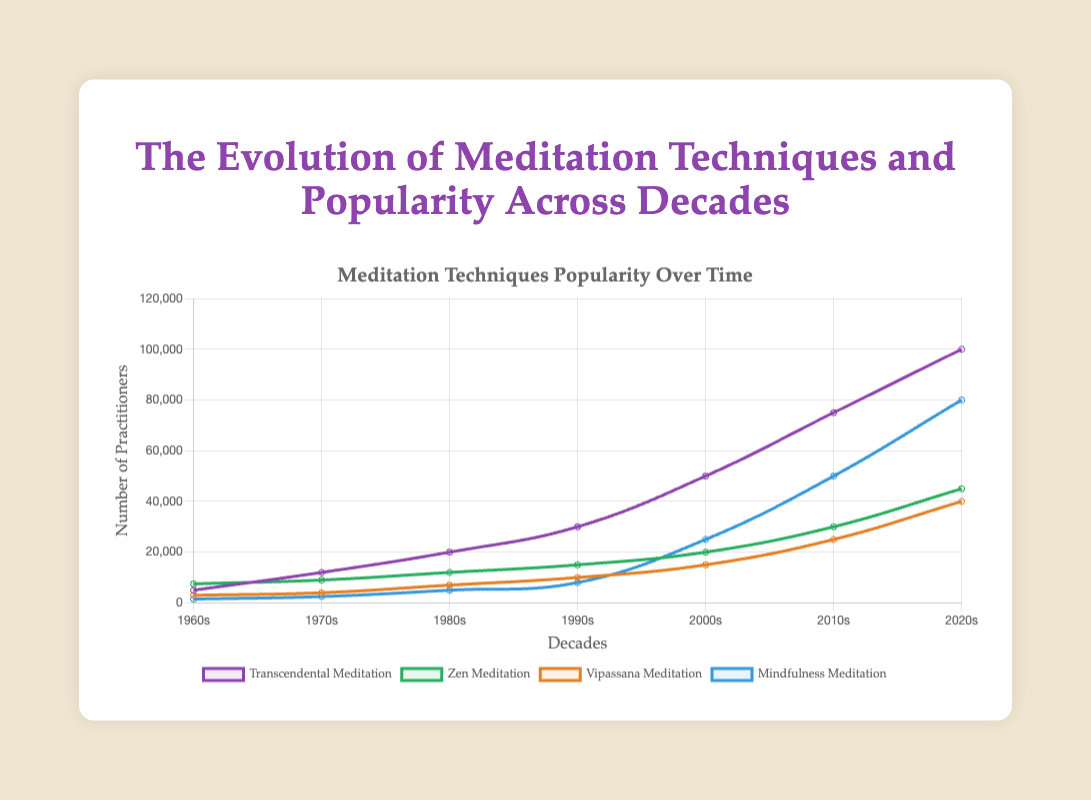Which meditation technique had the highest number of practitioners in the 1960s? The line chart shows the number of practitioners of different meditation techniques across decades. In the 1960s, Zen Meditation had the highest number of practitioners with 7500.
Answer: Zen Meditation What is the difference in the number of practitioners between Vipassana Meditation and Mindfulness Meditation in the 2020s? The chart indicates the number of practitioners for Vipassana Meditation as 40000 and Mindfulness Meditation as 80000 in the 2020s. Subtracting the two gives 80000 - 40000 = 40000.
Answer: 40000 Which meditation technique saw the largest growth in popularity from the 2000s to the 2010s? By observing the increase in the number of practitioners from the 2000s to the 2010s, Mindfulness Meditation grew from 25000 to 50000, Transcendental Meditation from 50000 to 75000, Zen Meditation from 20000 to 30000, and Vipassana Meditation from 15000 to 25000. The largest growth was for Mindfulness Meditation, which increased by 25000.
Answer: Mindfulness Meditation What is the combined number of practitioners for all meditation techniques in the 1980s? Add the number of practitioners for all techniques in the 1980s: (20000 for Transcendental Meditation) + (12000 for Zen Meditation) + (7000 for Vipassana Meditation) + (5000 for Mindfulness Meditation). Total = 20000 + 12000 + 7000 + 5000 = 44000.
Answer: 44000 Which decade saw the highest increase in the number of practitioners for Transcendental Meditation? Observing the increments across the decades: 1960s to 1970s (5000 to 12000 = 7000), 1970s to 1980s (12000 to 20000 = 8000), 1980s to 1990s (20000 to 30000 = 10000), 1990s to 2000s (30000 to 50000 = 20000), 2000s to 2010s (50000 to 75000 = 25000), 2010s to 2020s (75000 to 100000 = 25000). The highest increase was from the 2000s to 2010s and 2010s to 2020s, both with an increase of 25000.
Answer: 2000s to 2010s, 2010s to 2020s Which meditation technique had a consistent increase in practitioners across all decades? By analyzing the data, all the techniques (Transcendental Meditation, Zen Meditation, Vipassana Meditation, Mindfulness Meditation) had an increase in the number of practitioners across all decades without any decline.
Answer: All techniques Rank the meditation techniques based on the number of practitioners in the 2020s from highest to lowest. By referring to the chart for the 2020s: Transcendental Meditation (100000), Mindfulness Meditation (80000), Zen Meditation (45000), Vipassana Meditation (40000). The order from highest to lowest is: Transcendental Meditation, Mindfulness Meditation, Zen Meditation, Vipassana Meditation.
Answer: Transcendental Meditation, Mindfulness Meditation, Zen Meditation, Vipassana Meditation Calculate the average number of practitioners for Mindfulness Meditation from the 1960s to the 2020s. Sum up the number of practitioners for Mindfulness Meditation across all decades and then divide by the number of decades. (1500 + 2500 + 5000 + 8000 + 25000 + 50000 + 80000) / 7. Total = 172000; Average = 172000 / 7 = 24571.43.
Answer: 24571.43 